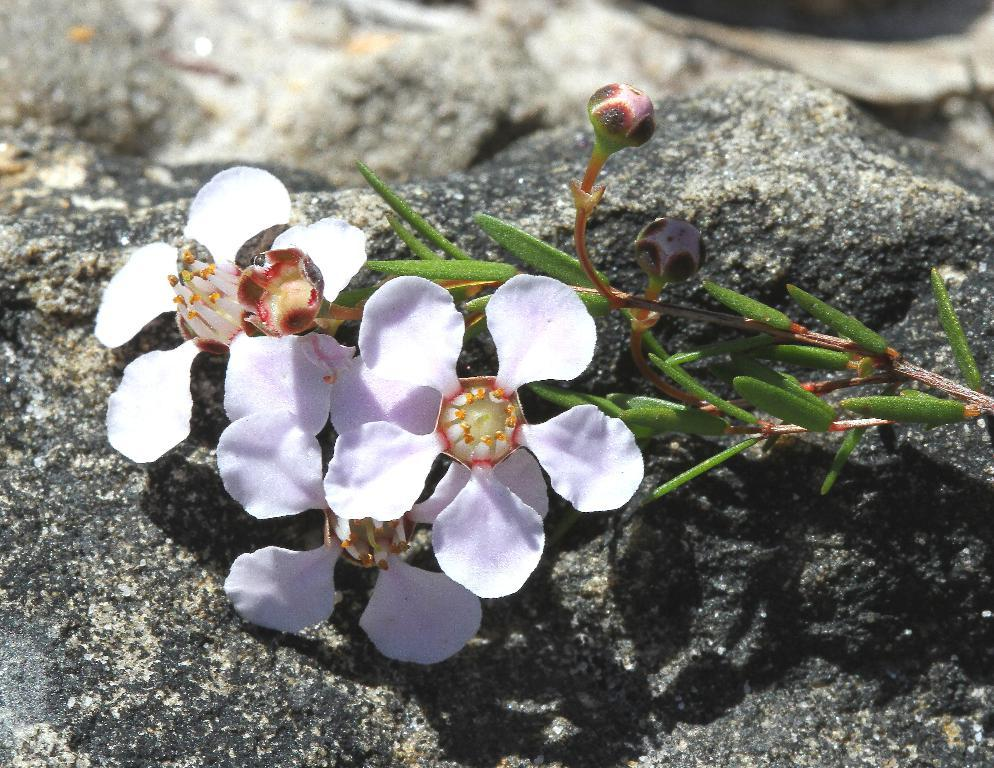What type of plants can be seen in the image? There are flowers, buds, and leaves in the image. Where are the flowers, buds, and leaves located? They are on a rock in the image. What part of the plants can be seen in the image? The flowers, buds, and leaves are visible. How is the background of the image depicted? The background of the image is blurred. What type of fang can be seen in the image? There is no fang present in the image; it features flowers, buds, and leaves on a rock. What kind of toys are visible in the image? There are no toys present in the image; it features flowers, buds, and leaves on a rock. 